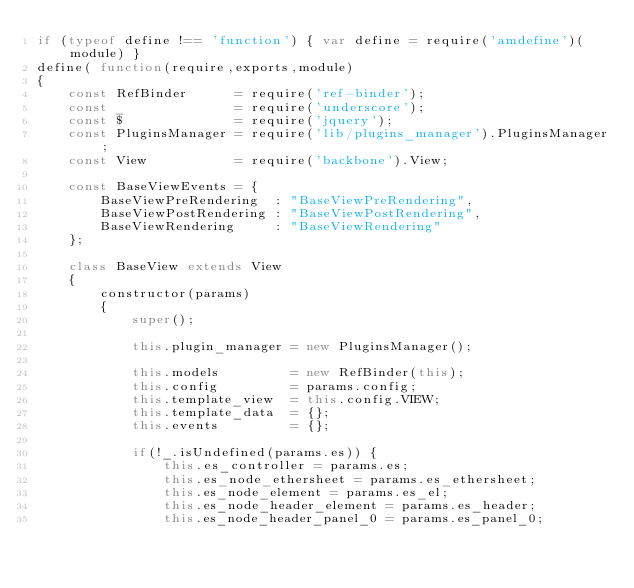Convert code to text. <code><loc_0><loc_0><loc_500><loc_500><_JavaScript_>if (typeof define !== 'function') { var define = require('amdefine')(module) }
define( function(require,exports,module)
{
    const RefBinder      = require('ref-binder');
    const _              = require('underscore');
    const $              = require('jquery');
    const PluginsManager = require('lib/plugins_manager').PluginsManager;
    const View           = require('backbone').View;

    const BaseViewEvents = {
        BaseViewPreRendering  : "BaseViewPreRendering",
        BaseViewPostRendering : "BaseViewPostRendering",
        BaseViewRendering     : "BaseViewRendering"
    };

    class BaseView extends View
    {
        constructor(params)
        {
            super();

            this.plugin_manager = new PluginsManager();

            this.models         = new RefBinder(this);
            this.config         = params.config;
            this.template_view  = this.config.VIEW;
            this.template_data  = {};
            this.events         = {};

            if(!_.isUndefined(params.es)) {
                this.es_controller = params.es;
                this.es_node_ethersheet = params.es_ethersheet;
                this.es_node_element = params.es_el;
                this.es_node_header_element = params.es_header;
                this.es_node_header_panel_0 = params.es_panel_0;</code> 